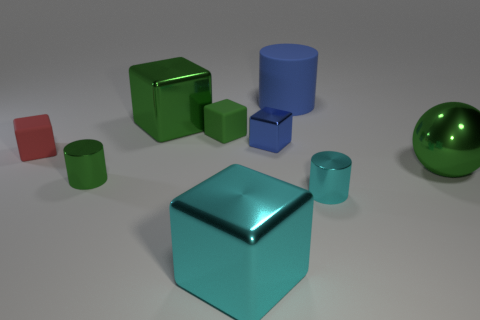What is the shape of the large metallic thing on the right side of the tiny cylinder that is right of the cube that is in front of the tiny red matte cube? sphere 